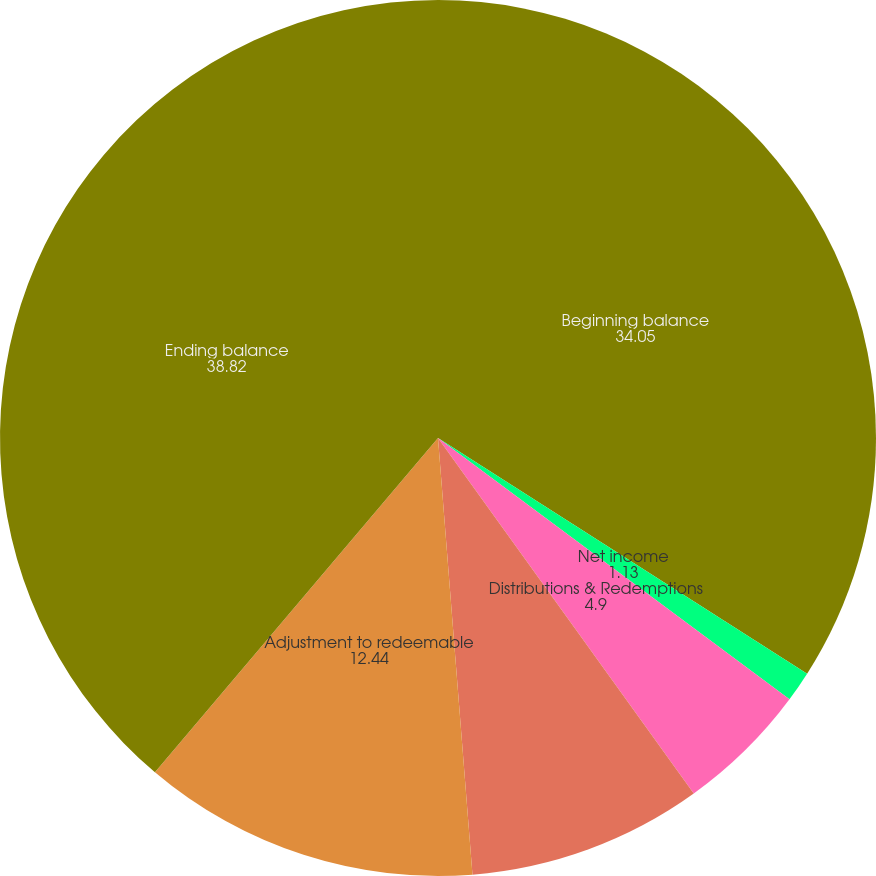<chart> <loc_0><loc_0><loc_500><loc_500><pie_chart><fcel>Beginning balance<fcel>Net income<fcel>Distributions & Redemptions<fcel>Contributions<fcel>Adjustment to redeemable<fcel>Ending balance<nl><fcel>34.05%<fcel>1.13%<fcel>4.9%<fcel>8.67%<fcel>12.44%<fcel>38.82%<nl></chart> 